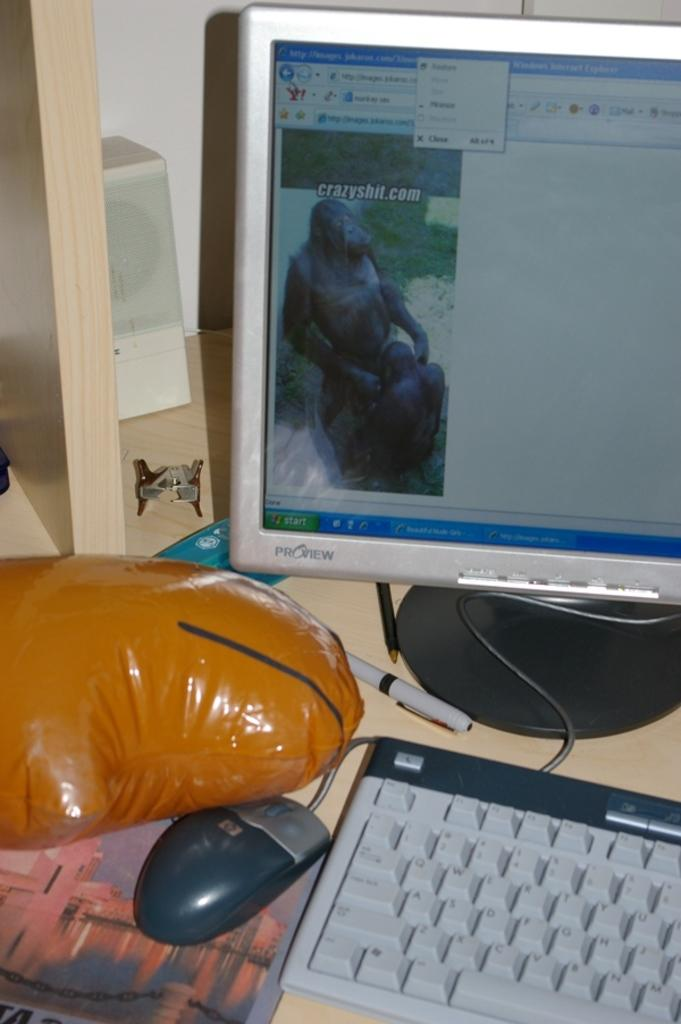What type of electronic device is visible in the image? There is a monitor in the image. What is used for input with the monitor? There is a keyboard and a mouse in the image. What is the mouse placed on in the image? There is a mouse pad in the image. What other objects are present on the table in the image? There is a ball, a pen, and a pencil in the image. What type of toothpaste is used to clean the monitor in the image? There is no toothpaste present in the image, and toothpaste is not used to clean a monitor. 